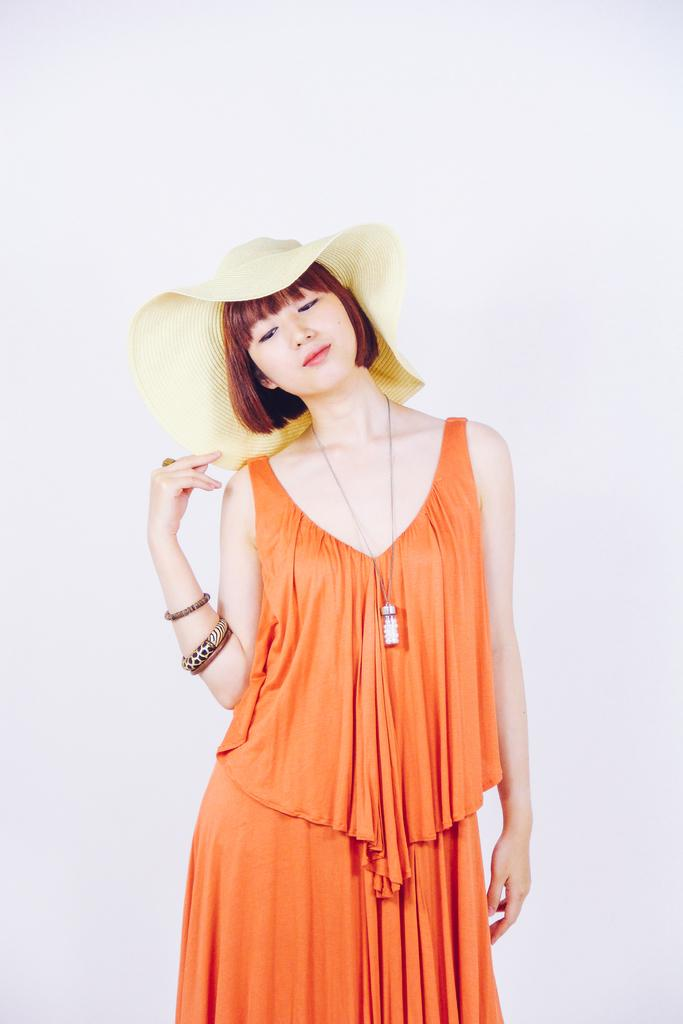Who is present in the image? There is a woman in the image. What is the woman wearing on her head? The woman is wearing a hat. What color is the woman's dress? The woman is wearing an orange dress. What accessories is the woman wearing on her arms? The woman is wearing bangles. What piece of jewelry is the woman wearing around her neck? The woman is wearing a locket. What can be seen in the background of the image? There is a wall visible in the background of the image. What type of honey is the woman holding in the image? There is no honey present in the image; the woman is not holding any honey. How many beds are visible in the image? There are no beds visible in the image; the focus is on the woman and her clothing and accessories. 